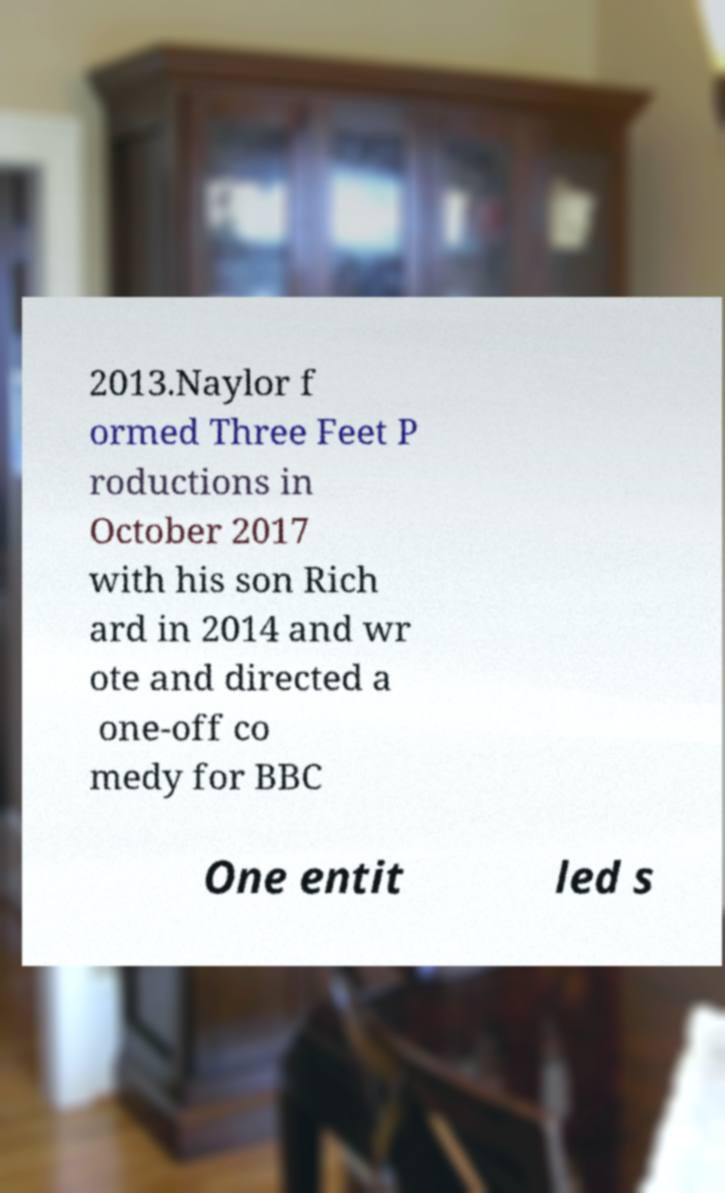There's text embedded in this image that I need extracted. Can you transcribe it verbatim? 2013.Naylor f ormed Three Feet P roductions in October 2017 with his son Rich ard in 2014 and wr ote and directed a one-off co medy for BBC One entit led s 